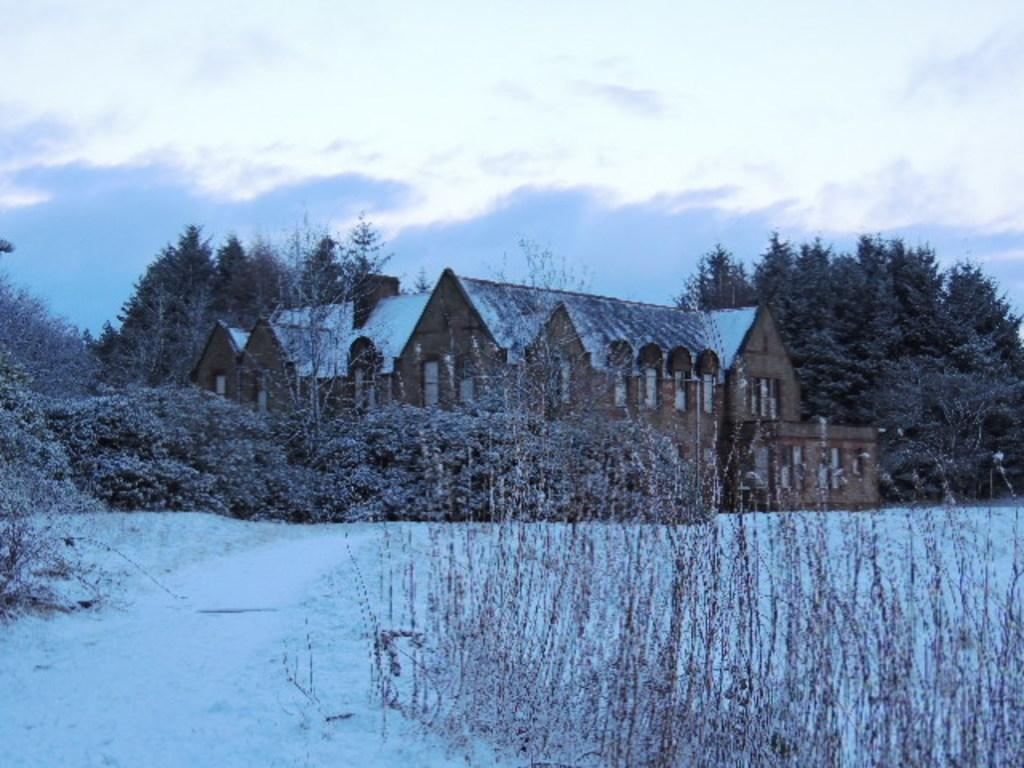What type of structure is present in the image? There is a house in the image. What natural elements can be seen in the image? There are trees and plants in the image. What weather condition is depicted in the image? There is snow visible in the image. What can be seen in the background of the image? The sky with clouds is visible in the background of the image. What type of knot is used to secure the nation's flag in the image? There is no flag or knot present in the image. What material is the brass used for in the image? There is no brass present in the image. 